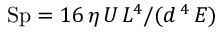Convert formula to latex. <formula><loc_0><loc_0><loc_500><loc_500>S p = { 1 6 \, \eta \, U \, L ^ { 4 } } / ( d \, ^ { 4 } \, E )</formula> 